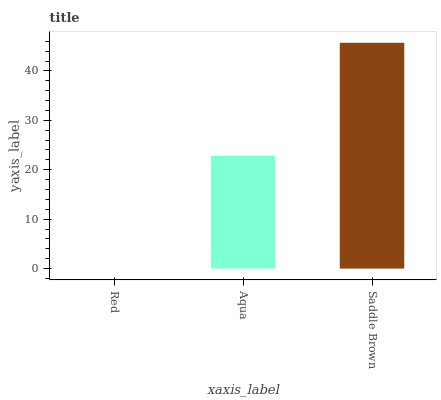Is Red the minimum?
Answer yes or no. Yes. Is Saddle Brown the maximum?
Answer yes or no. Yes. Is Aqua the minimum?
Answer yes or no. No. Is Aqua the maximum?
Answer yes or no. No. Is Aqua greater than Red?
Answer yes or no. Yes. Is Red less than Aqua?
Answer yes or no. Yes. Is Red greater than Aqua?
Answer yes or no. No. Is Aqua less than Red?
Answer yes or no. No. Is Aqua the high median?
Answer yes or no. Yes. Is Aqua the low median?
Answer yes or no. Yes. Is Red the high median?
Answer yes or no. No. Is Red the low median?
Answer yes or no. No. 